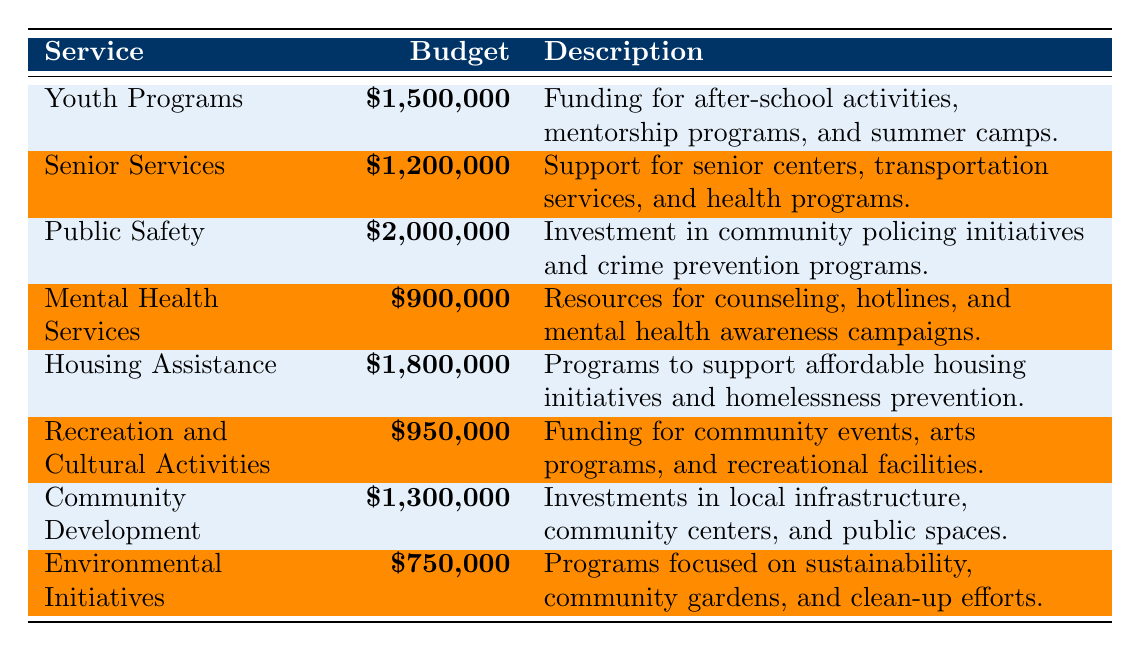What's the total allocation for Youth Programs and Housing Assistance? The budget for Youth Programs is $1,500,000 and for Housing Assistance is $1,800,000. Adding these two values: $1,500,000 + $1,800,000 = $3,300,000.
Answer: $3,300,000 Which service has the highest budget allocation? The budget allocation for Public Safety is $2,000,000, which is higher than any other service listed in the table.
Answer: Public Safety How much less is allocated to Environmental Initiatives compared to Mental Health Services? The budget for Environmental Initiatives is $750,000 and for Mental Health Services is $900,000. The difference is $900,000 - $750,000 = $150,000.
Answer: $150,000 What is the total budget allocated for Senior Services and Community Development? The budget for Senior Services is $1,200,000 and for Community Development is $1,300,000. Adding these two: $1,200,000 + $1,300,000 = $2,500,000.
Answer: $2,500,000 Is the budget for Recreation and Cultural Activities greater than that of Mental Health Services? The budget for Recreation and Cultural Activities is $950,000 and for Mental Health Services is $900,000. Since $950,000 is greater than $900,000, the statement is true.
Answer: Yes What percentage of the total budget allocation does Youth Programs receive? The total budget for all services is $1,500,000 + $1,200,000 + $2,000,000 + $900,000 + $1,800,000 + $950,000 + $1,300,000 + $750,000 = $10,400,000. The allocation for Youth Programs is $1,500,000, so the percentage is ($1,500,000 / $10,400,000) * 100 = 14.42%.
Answer: 14.42% If the budget for Mental Health Services were doubled, what would the new total budget be? The current budget for Mental Health Services is $900,000. If doubled, it becomes $900,000 * 2 = $1,800,000. The new total budget would be $10,400,000 - $900,000 + $1,800,000 = $11,300,000.
Answer: $11,300,000 What is the average budget of all services listed? The total budget for all services is $10,400,000 and there are 8 services listed. To find the average, we calculate $10,400,000 / 8 = $1,300,000.
Answer: $1,300,000 Which service receives less than $1,000,000 in budget? The services that receive less than $1,000,000 are Mental Health Services ($900,000) and Environmental Initiatives ($750,000).
Answer: Mental Health Services and Environmental Initiatives What is the combined budget for Public Safety and Housing Assistance? The budget for Public Safety is $2,000,000 and for Housing Assistance is $1,800,000. Their combined budget is $2,000,000 + $1,800,000 = $3,800,000.
Answer: $3,800,000 